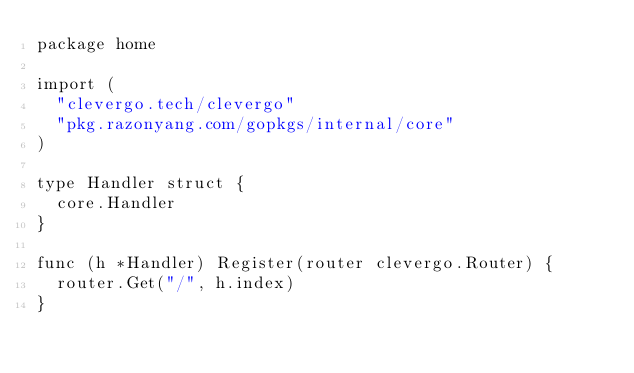Convert code to text. <code><loc_0><loc_0><loc_500><loc_500><_Go_>package home

import (
	"clevergo.tech/clevergo"
	"pkg.razonyang.com/gopkgs/internal/core"
)

type Handler struct {
	core.Handler
}

func (h *Handler) Register(router clevergo.Router) {
	router.Get("/", h.index)
}
</code> 